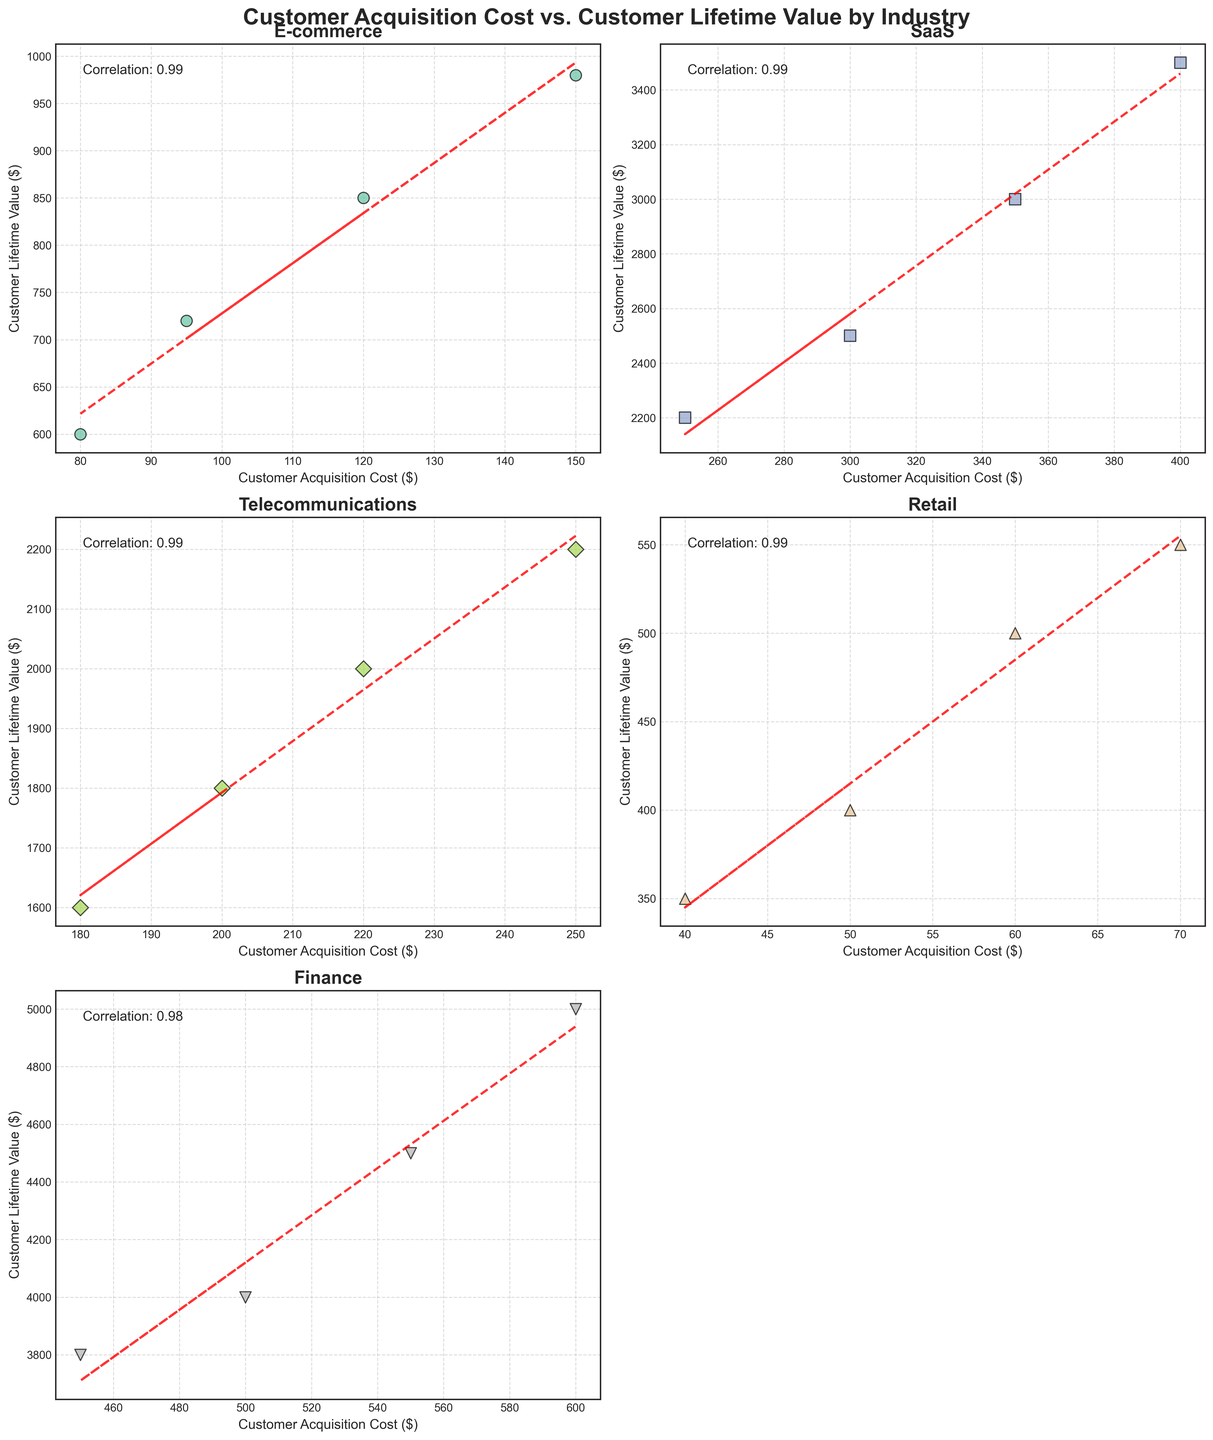What is the title of the figure? The title is located at the top of the figure, clearly stating what the figure is about. By reading it, you can determine the title.
Answer: Customer Acquisition Cost vs. Customer Lifetime Value by Industry How many industries are represented in the figure? The figure consists of multiple subplots, each representing a certain industry. By counting each subplot's titles, you can determine the number of distinct industries shown.
Answer: 5 What is the correlation coefficient for the Finance industry? The correlation coefficient is a measure of the linear relationship between customer acquisition cost and customer lifetime value. In the subplot for the Finance industry, a text annotation indicates this coefficient.
Answer: 0.99 Which industry has the highest customer lifetime value? By inspecting the y-axis values and comparing the highest data points across all industry subplots, you can identify which industry has the highest customer lifetime value.
Answer: Finance Compare the customer acquisition costs between E-commerce and SaaS industries. To compare, look at the x-axis values in the subplots for E-commerce and SaaS. Identify the range of customer acquisition costs in each subplot and compare these ranges.
Answer: SaaS has higher customer acquisition costs than E-commerce What industry has the least variation in customer acquisition costs? Variation can be visually assessed by seeing how spread out the points are along the x-axis in each industry’s subplot. The industry with the points closest together has the least variation.
Answer: Retail Which industry has the steepest trend line slope? The slope of the trend line indicates how quickly values are increasing. By comparing the angles of the red dashed lines in each subplot, we can deduce which is steepest.
Answer: Finance How does the correlation in Retail compare to Telecommunications? Look at the text annotations for correlation in the subplots for Retail and Telecommunications. Compare the numerical values to determine the relative strength of the linear relationships.
Answer: Telecommunications has a higher correlation What is the average customer lifetime value in E-commerce? To determine the average, sum all customer lifetime values in the E-commerce subplot and divide by the number of points (4). (850 + 720 + 980 + 600) / 4 = 3125 / 4 = 781.25
Answer: 781.25 In which industry does increasing customer acquisition cost correlate most strongly with increasing customer lifetime value? The correlation coefficient in each subplot indicates the strength of the correlation. The higher the coefficient, the stronger the correlation.
Answer: Finance 